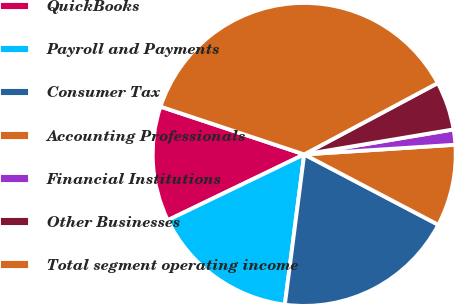Convert chart to OTSL. <chart><loc_0><loc_0><loc_500><loc_500><pie_chart><fcel>QuickBooks<fcel>Payroll and Payments<fcel>Consumer Tax<fcel>Accounting Professionals<fcel>Financial Institutions<fcel>Other Businesses<fcel>Total segment operating income<nl><fcel>12.26%<fcel>15.81%<fcel>19.35%<fcel>8.71%<fcel>1.62%<fcel>5.17%<fcel>37.08%<nl></chart> 